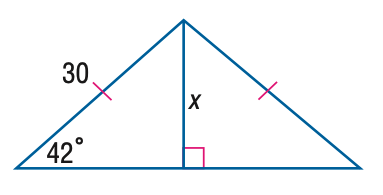Question: Find x. Round to the nearest tenth.
Choices:
A. 20.1
B. 21.2
C. 22.3
D. 23.4
Answer with the letter. Answer: A 